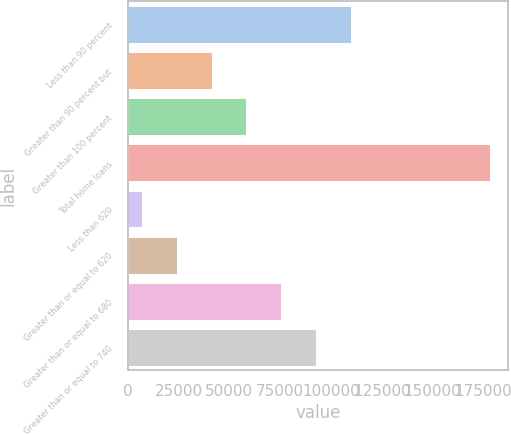Convert chart. <chart><loc_0><loc_0><loc_500><loc_500><bar_chart><fcel>Less than 90 percent<fcel>Greater than 90 percent but<fcel>Greater than 100 percent<fcel>Total home loans<fcel>Less than 620<fcel>Greater than or equal to 620<fcel>Greater than or equal to 680<fcel>Greater than or equal to 740<nl><fcel>109810<fcel>41283.4<fcel>58415.1<fcel>178337<fcel>7020<fcel>24151.7<fcel>75546.8<fcel>92678.5<nl></chart> 